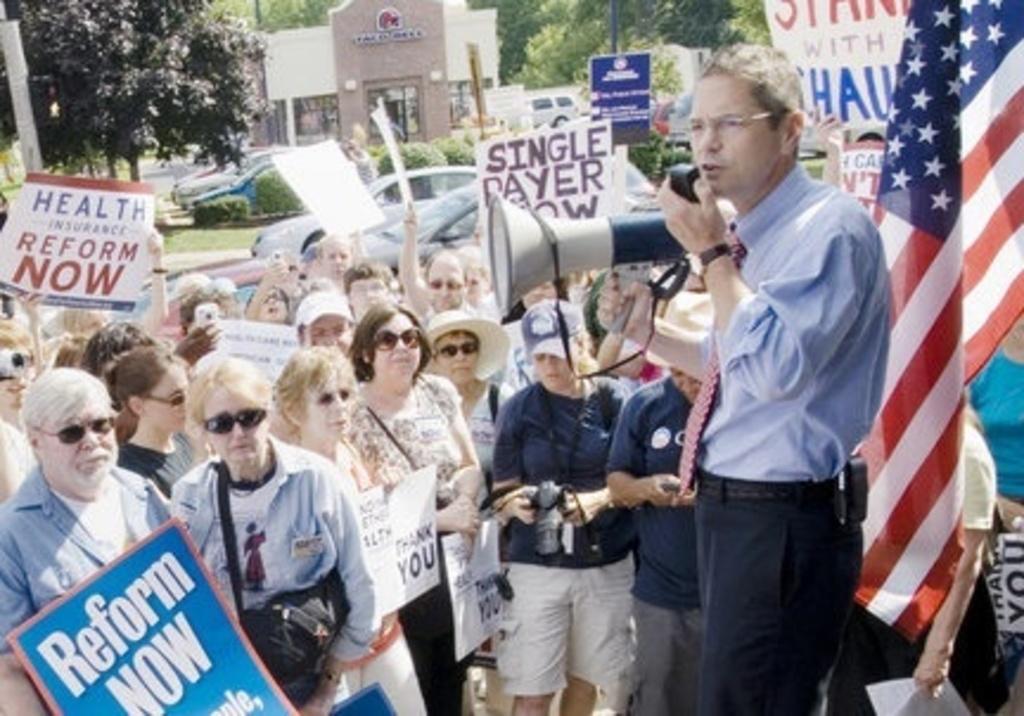Can you describe this image briefly? In this image there is a person holding the speaker in his hand and placed it in front of his mouth, in front of them there are so many people standing and few is holding posters with some text in it, behind them there are few vehicles moving on the road. In the middle of the road there are trees, plants, few poles and a board with some text. In the background there is a building and trees. On the right side of the image there is a flag. 